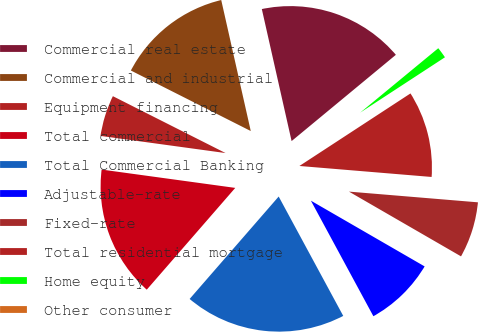Convert chart to OTSL. <chart><loc_0><loc_0><loc_500><loc_500><pie_chart><fcel>Commercial real estate<fcel>Commercial and industrial<fcel>Equipment financing<fcel>Total commercial<fcel>Total Commercial Banking<fcel>Adjustable-rate<fcel>Fixed-rate<fcel>Total residential mortgage<fcel>Home equity<fcel>Other consumer<nl><fcel>17.53%<fcel>14.03%<fcel>5.27%<fcel>15.78%<fcel>19.28%<fcel>8.77%<fcel>7.02%<fcel>10.53%<fcel>1.77%<fcel>0.02%<nl></chart> 